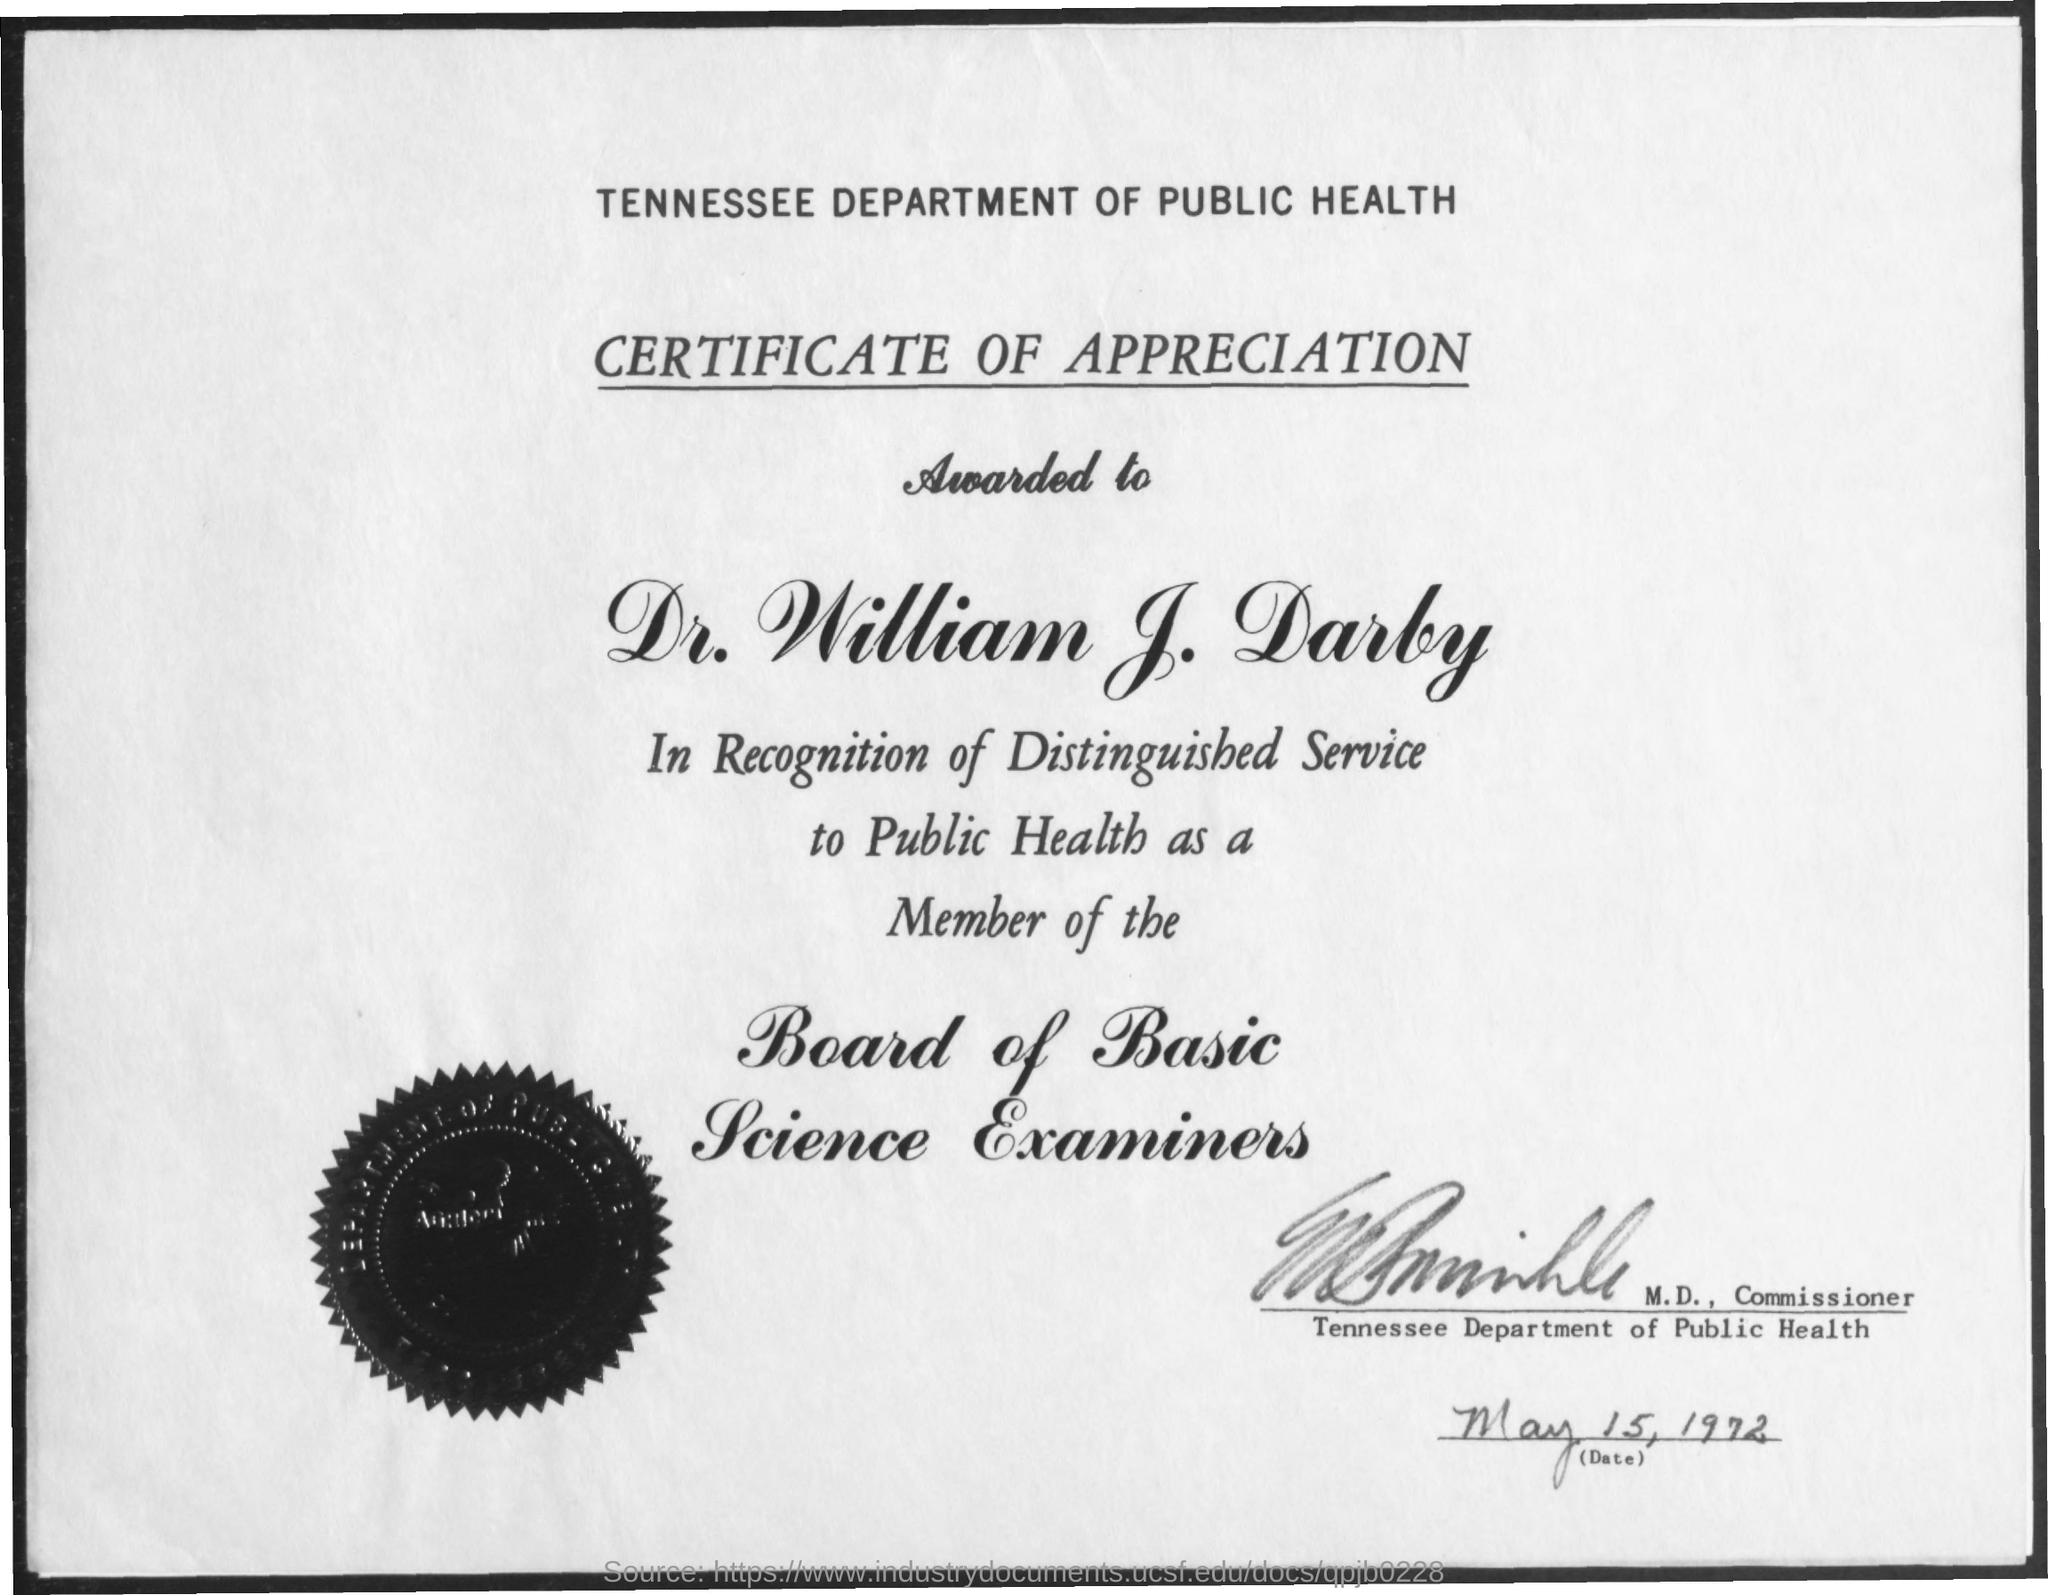What is the department mentioned?
Provide a succinct answer. TENNESSEE DEPARTMENT OF PUBLIC HEALTH. What is the certificate about?
Provide a short and direct response. CERTIFICATE OF APPRECIATION. What is the board about?
Your answer should be very brief. Board of Basic Science Examiners. 